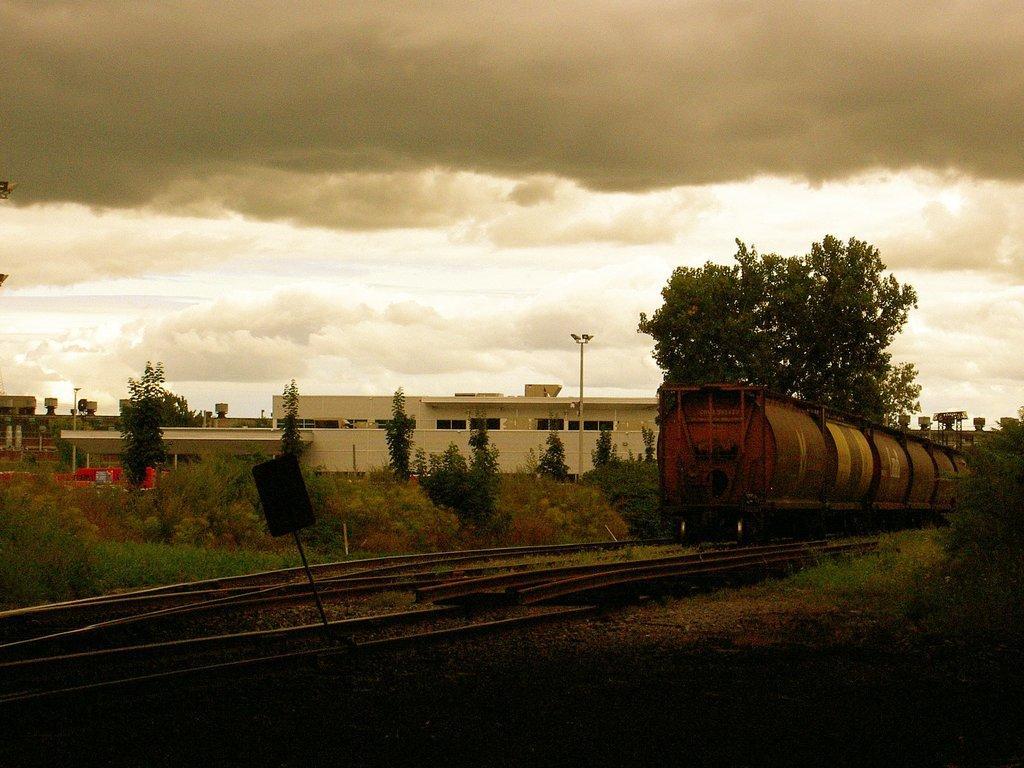Can you describe this image briefly? There is a train moving on the railway track and around the train there are some houses and trees. 